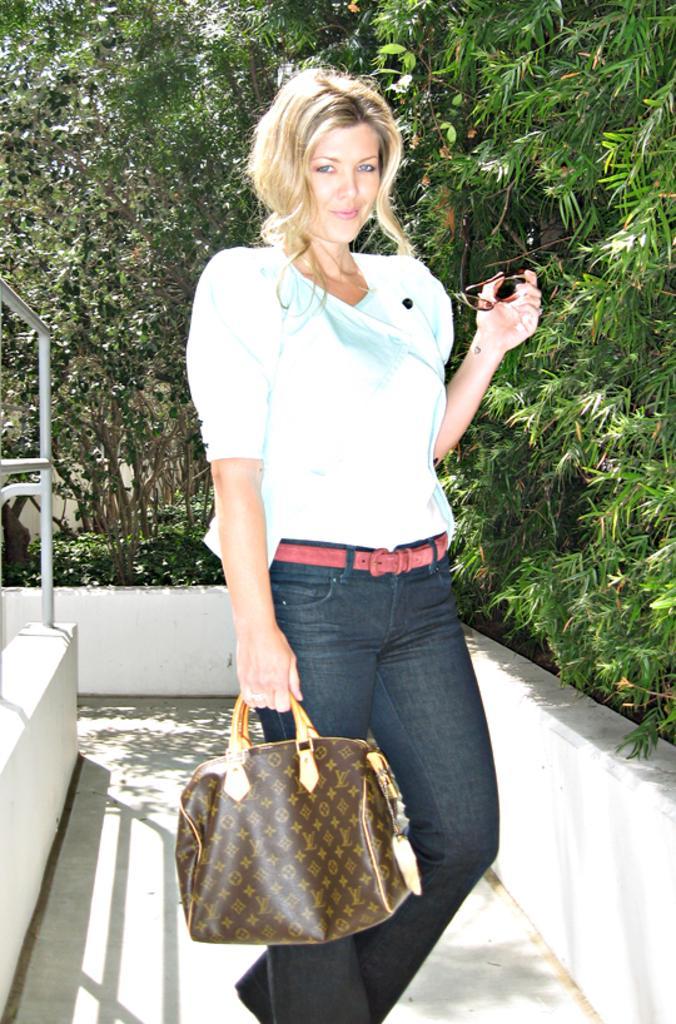In one or two sentences, can you explain what this image depicts? As we can see in the image there are trees, a women standing over here and she is holding brown color handbag. This woman is wearing white color shirt, black color jeans, pink color belt and on the other hand she is holding spectacles. 